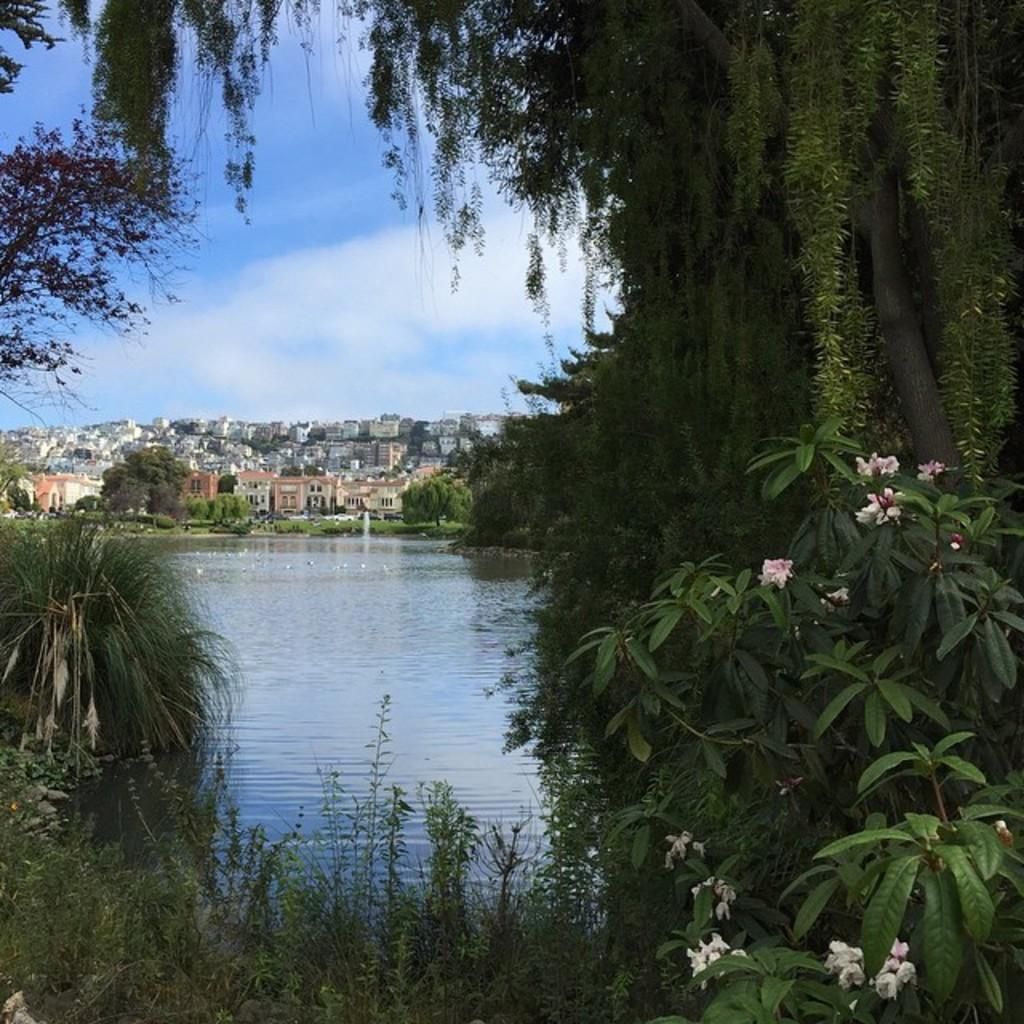What can be seen in the foreground of the image? In the foreground of the image, there is a group of flowers on plants, a lake with water, and a group of trees. What is visible in the background of the image? In the background of the image, there are buildings and a cloudy sky. How many different types of natural elements are present in the foreground of the image? There are three different types of natural elements in the foreground: flowers, water, and trees. Where is the playground located in the image? There is no playground present in the image. How many caves can be seen in the background of the image? There are no caves visible in the image; only buildings and a cloudy sky are present in the background. 